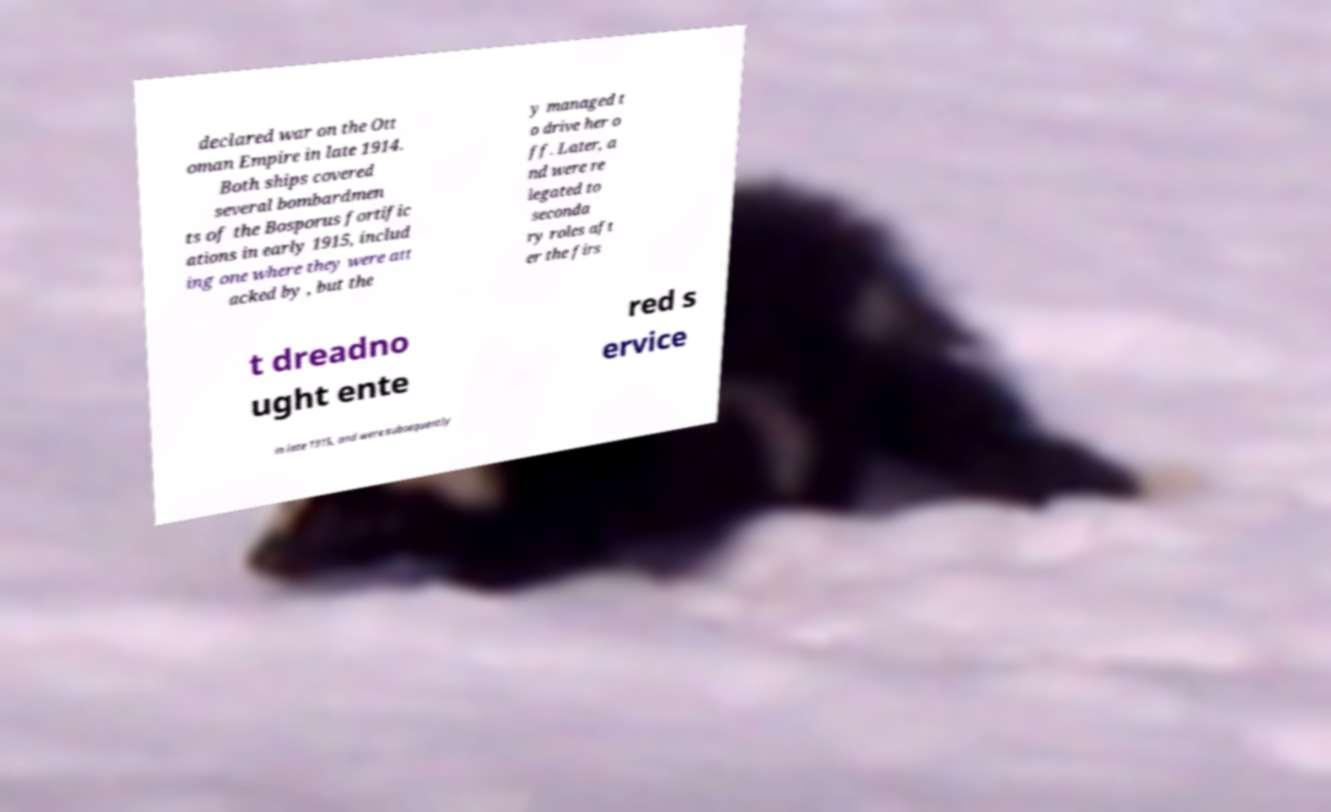What messages or text are displayed in this image? I need them in a readable, typed format. declared war on the Ott oman Empire in late 1914. Both ships covered several bombardmen ts of the Bosporus fortific ations in early 1915, includ ing one where they were att acked by , but the y managed t o drive her o ff. Later, a nd were re legated to seconda ry roles aft er the firs t dreadno ught ente red s ervice in late 1915, and were subsequently 